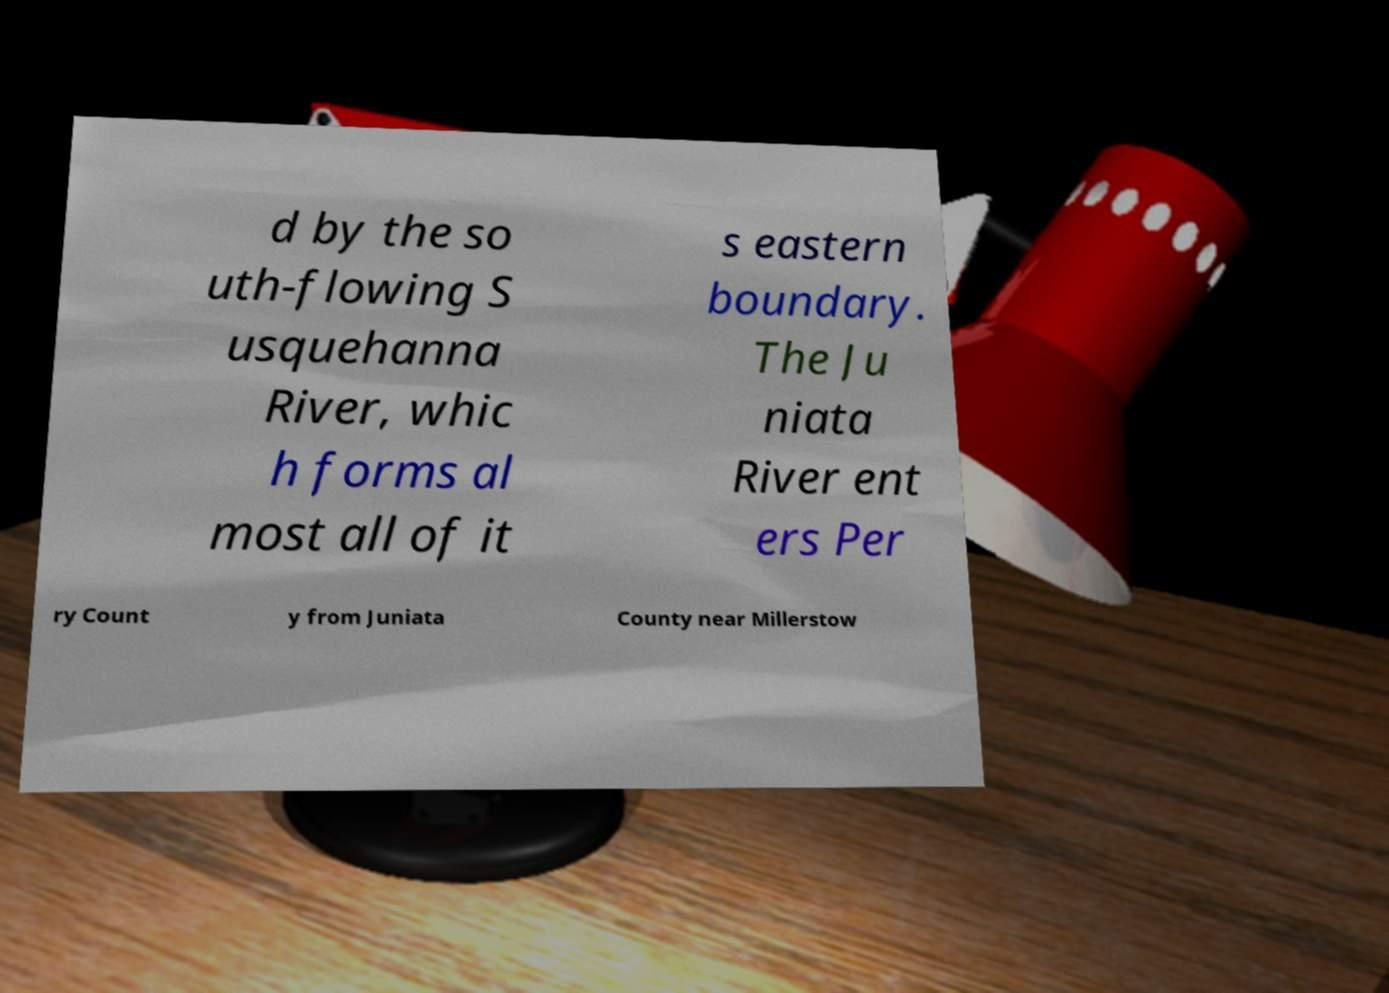What messages or text are displayed in this image? I need them in a readable, typed format. d by the so uth-flowing S usquehanna River, whic h forms al most all of it s eastern boundary. The Ju niata River ent ers Per ry Count y from Juniata County near Millerstow 